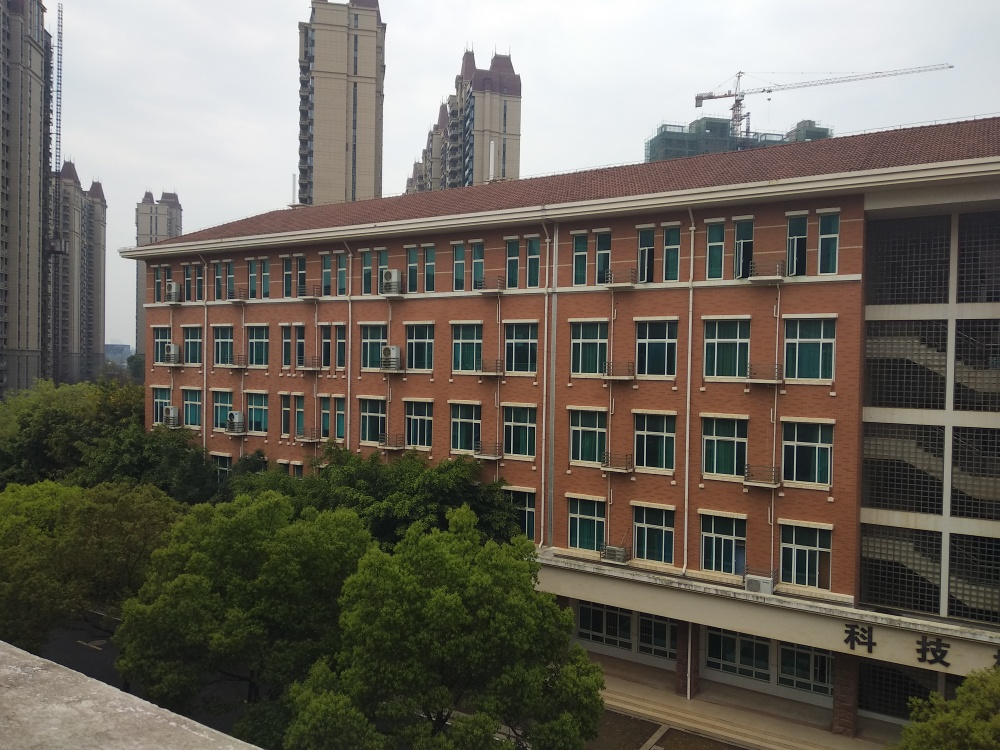What time of year does the image suggest? The image suggests a time of year that is neither in the peak of winter nor the height of summer. The leaves on the trees are green and full, indicating it could be either spring or summer. The absence of people and the lighting suggest it might be during the workday, but there are no definitive seasonal indicators such as snow or autumn leaves. 